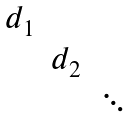Convert formula to latex. <formula><loc_0><loc_0><loc_500><loc_500>\begin{matrix} d _ { 1 } & & \\ & d _ { 2 } & \\ & & \ddots \end{matrix}</formula> 